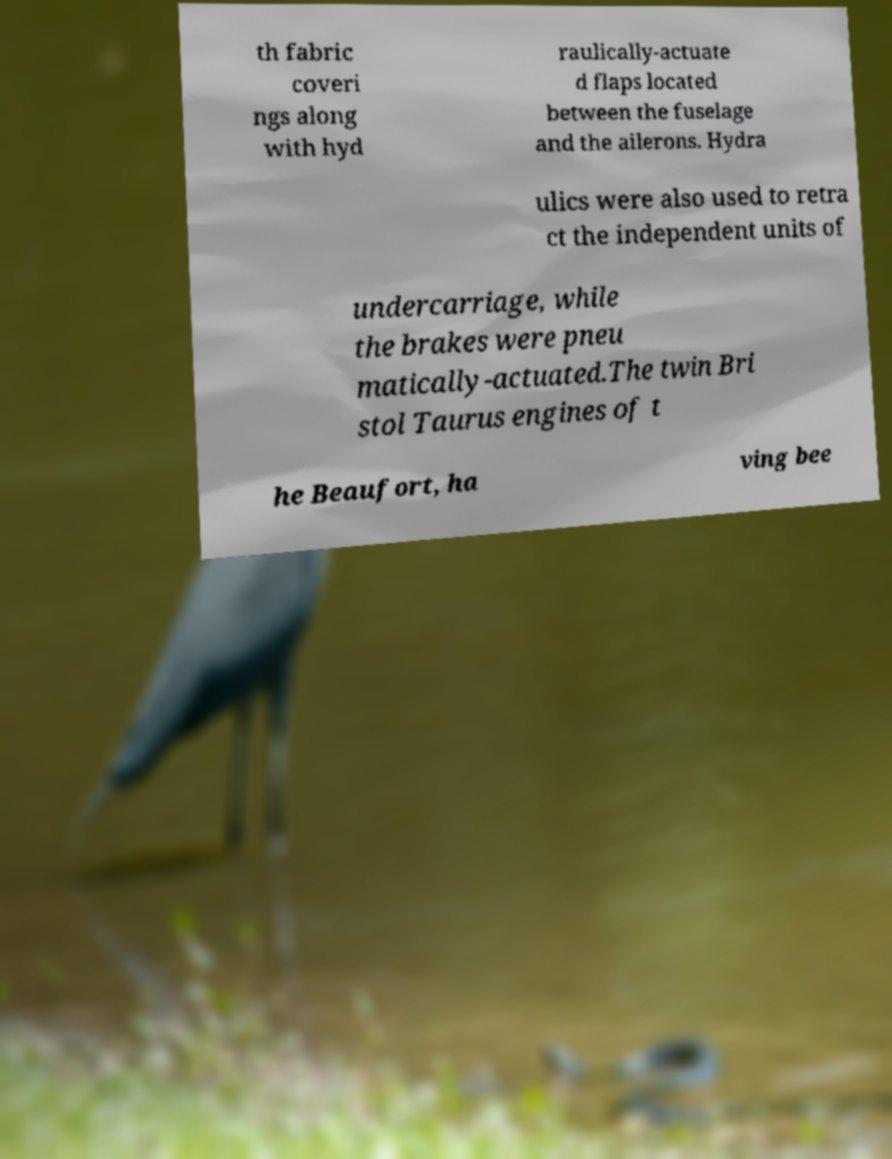Can you read and provide the text displayed in the image?This photo seems to have some interesting text. Can you extract and type it out for me? th fabric coveri ngs along with hyd raulically-actuate d flaps located between the fuselage and the ailerons. Hydra ulics were also used to retra ct the independent units of undercarriage, while the brakes were pneu matically-actuated.The twin Bri stol Taurus engines of t he Beaufort, ha ving bee 